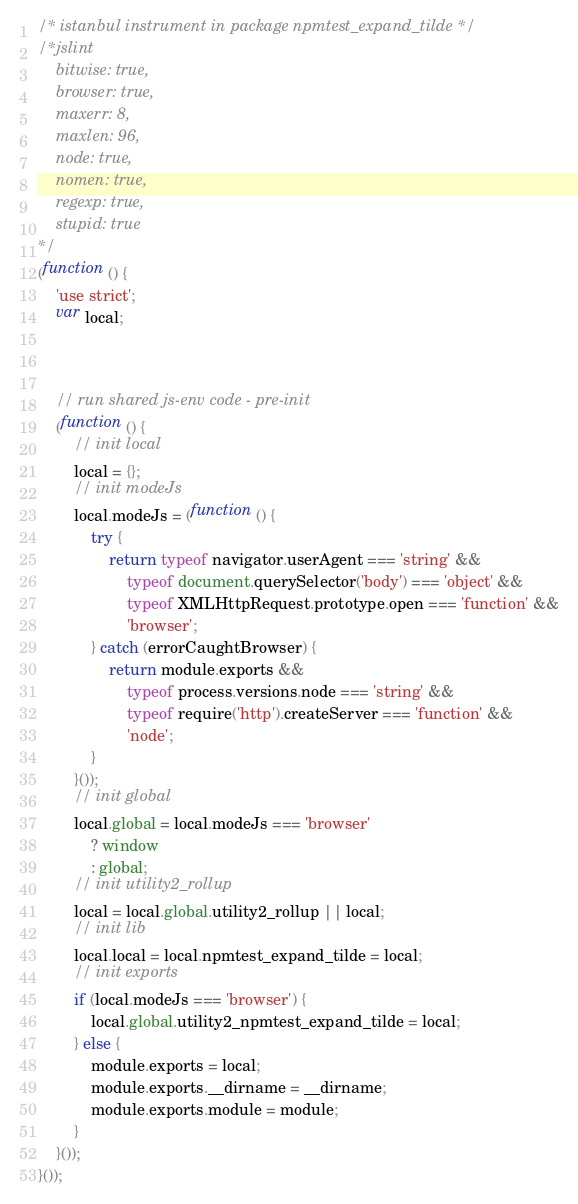<code> <loc_0><loc_0><loc_500><loc_500><_JavaScript_>/* istanbul instrument in package npmtest_expand_tilde */
/*jslint
    bitwise: true,
    browser: true,
    maxerr: 8,
    maxlen: 96,
    node: true,
    nomen: true,
    regexp: true,
    stupid: true
*/
(function () {
    'use strict';
    var local;



    // run shared js-env code - pre-init
    (function () {
        // init local
        local = {};
        // init modeJs
        local.modeJs = (function () {
            try {
                return typeof navigator.userAgent === 'string' &&
                    typeof document.querySelector('body') === 'object' &&
                    typeof XMLHttpRequest.prototype.open === 'function' &&
                    'browser';
            } catch (errorCaughtBrowser) {
                return module.exports &&
                    typeof process.versions.node === 'string' &&
                    typeof require('http').createServer === 'function' &&
                    'node';
            }
        }());
        // init global
        local.global = local.modeJs === 'browser'
            ? window
            : global;
        // init utility2_rollup
        local = local.global.utility2_rollup || local;
        // init lib
        local.local = local.npmtest_expand_tilde = local;
        // init exports
        if (local.modeJs === 'browser') {
            local.global.utility2_npmtest_expand_tilde = local;
        } else {
            module.exports = local;
            module.exports.__dirname = __dirname;
            module.exports.module = module;
        }
    }());
}());
</code> 